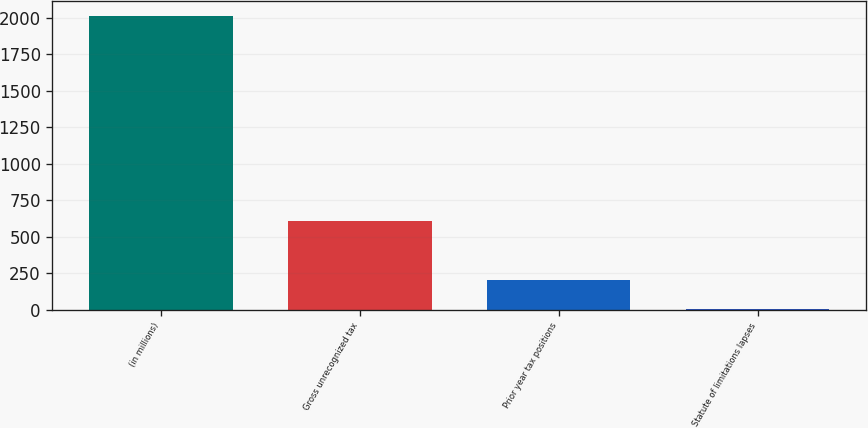Convert chart. <chart><loc_0><loc_0><loc_500><loc_500><bar_chart><fcel>(in millions)<fcel>Gross unrecognized tax<fcel>Prior year tax positions<fcel>Statute of limitations lapses<nl><fcel>2014<fcel>604.9<fcel>202.3<fcel>1<nl></chart> 